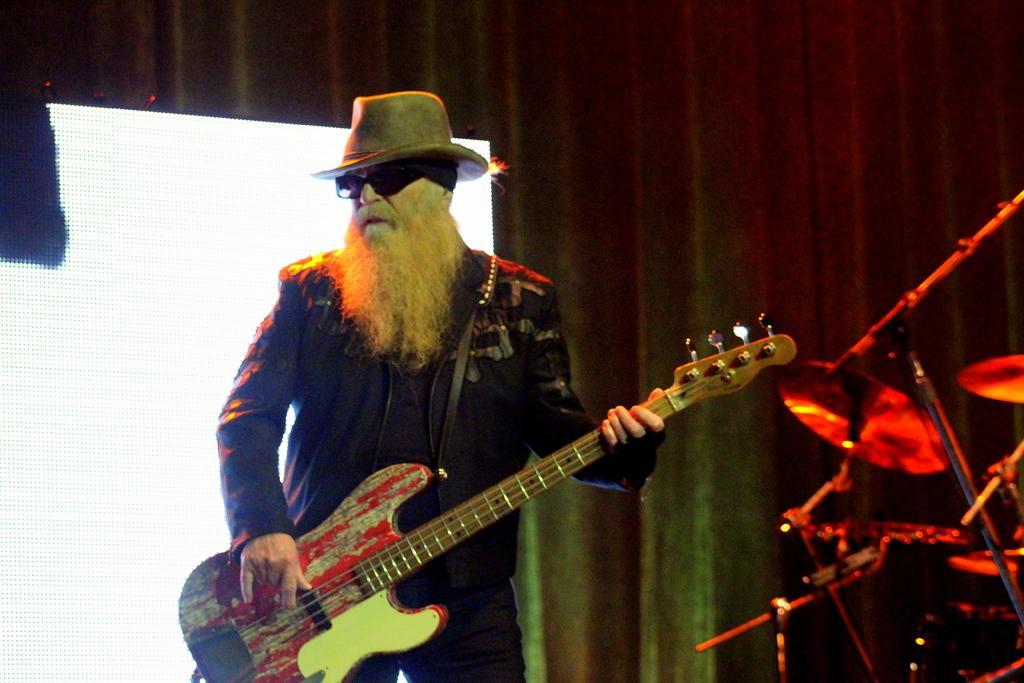In one or two sentences, can you explain what this image depicts? As we can see in the image there is a man holding guitar. On the right side there are guitars. 